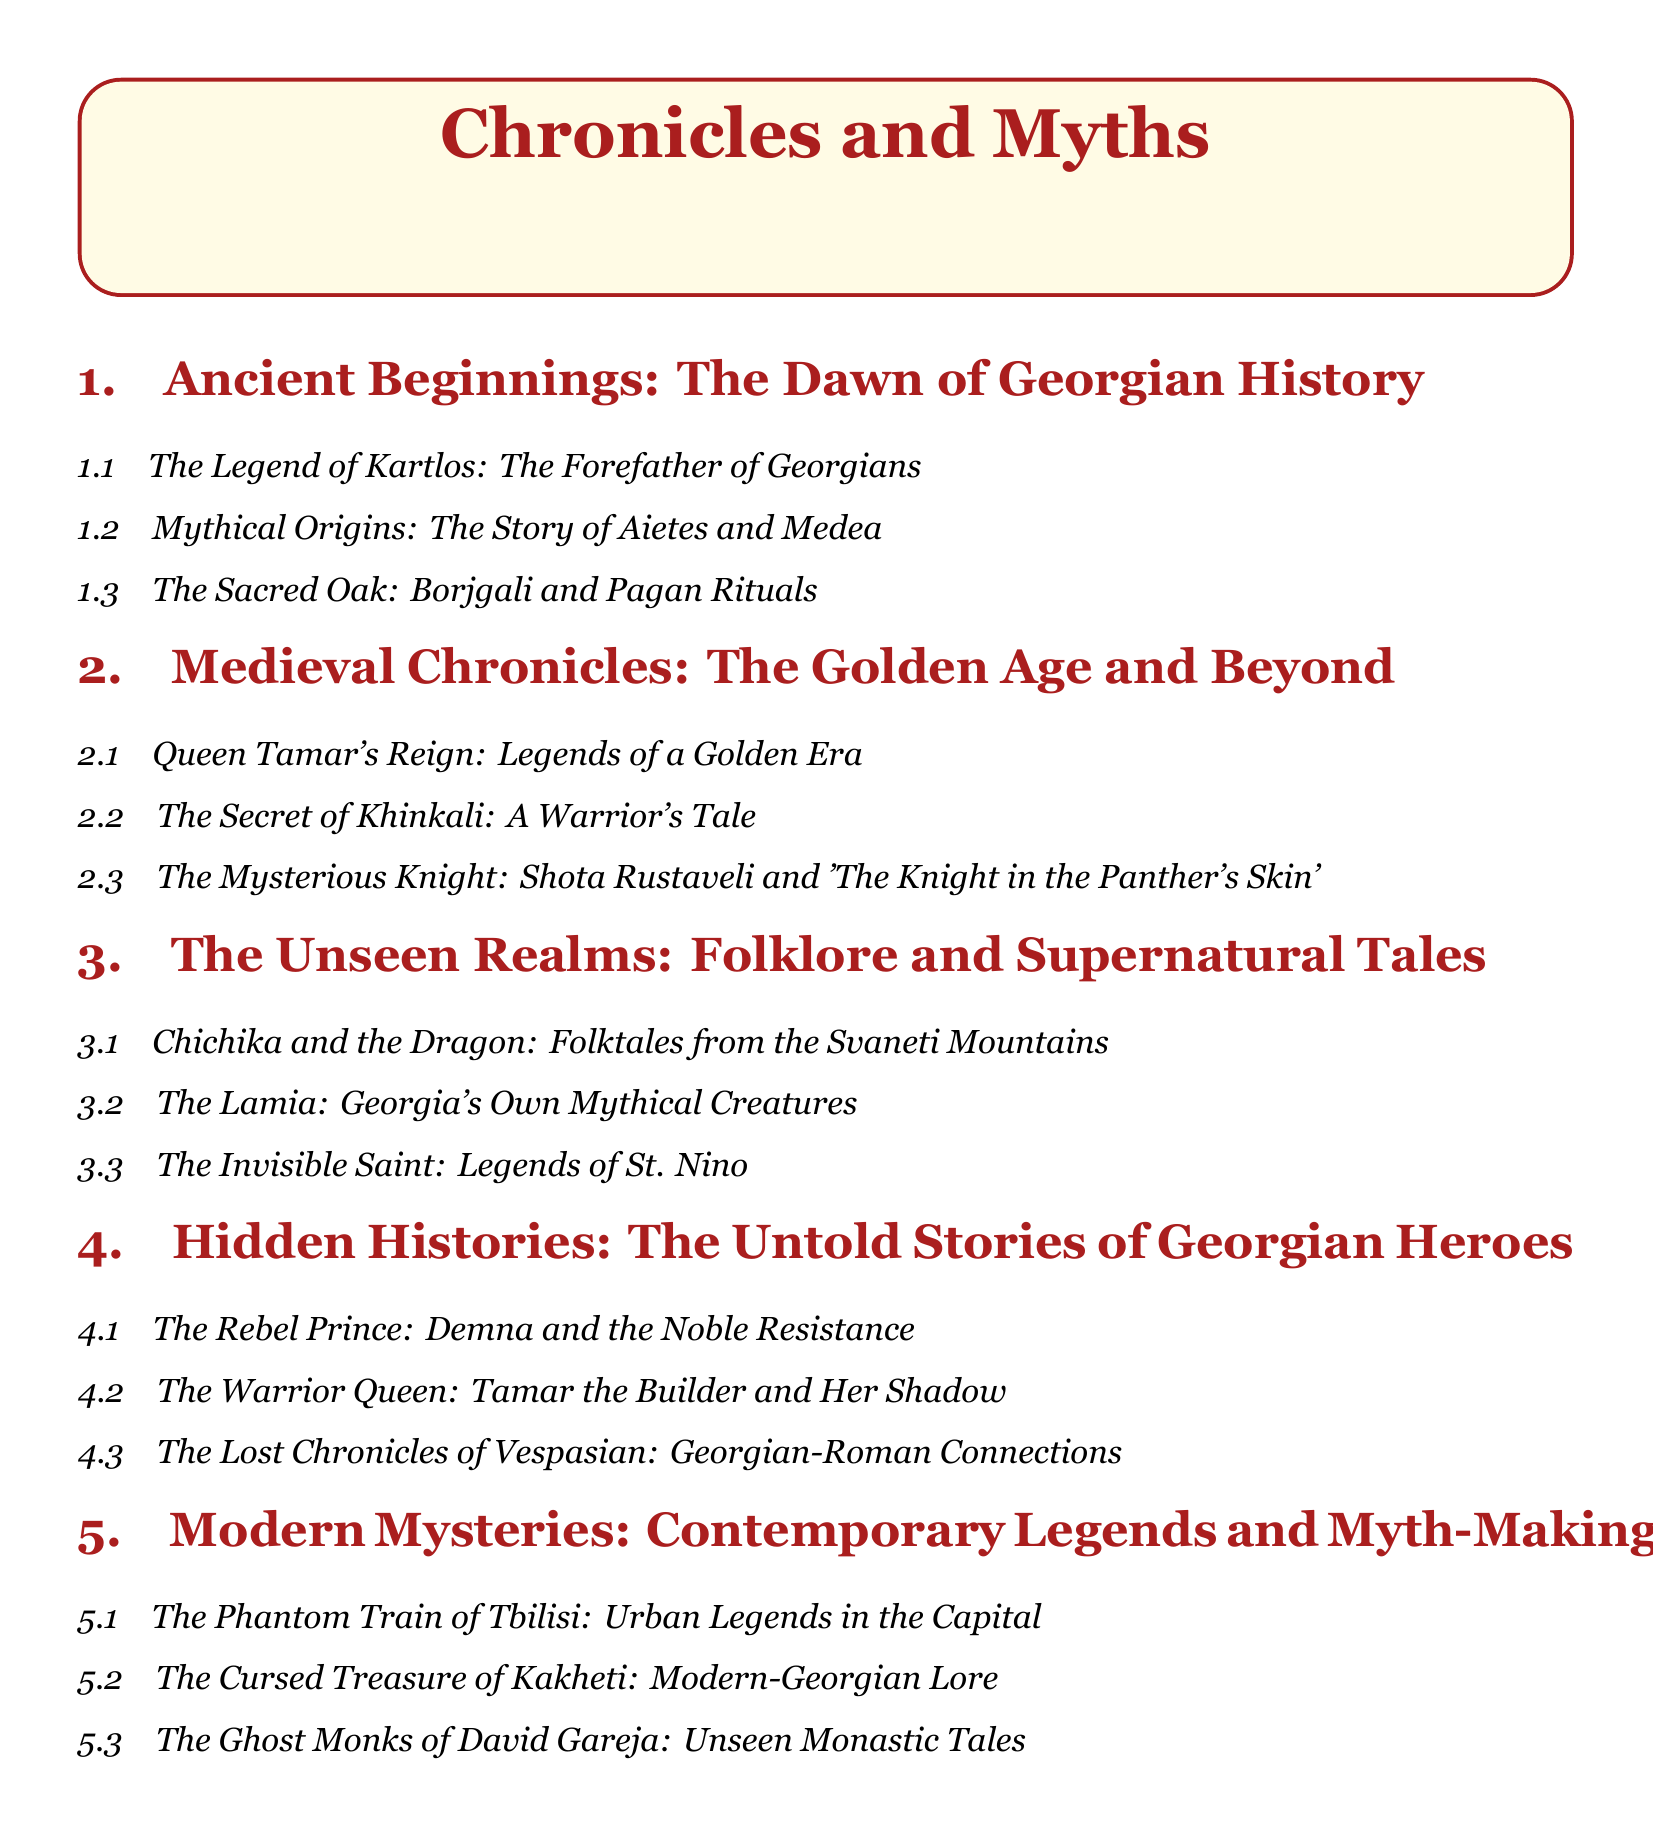What is the first section of the document? The first section is titled under "Ancient Beginnings," marking the start of the document's exploration into Georgian history.
Answer: Ancient Beginnings: The Dawn of Georgian History Who is referred to as the forefather of Georgians? The document specifically names Kartlos as the legendary forefather at the beginning of the Chronicles and Myths.
Answer: Kartlos What is the title of Shota Rustaveli's work mentioned? The document includes a specific title associated with Rustaveli, a central character in Georgian literature and history.
Answer: The Knight in the Panther's Skin How many subsections are there under "Hidden Histories"? This requires counting the subsections in the specified section of the document for accuracy.
Answer: Three What legendary figure is involved in the story of Medea? The document links Aietes with Medea, connecting these mythological figures to Georgian heritage.
Answer: Aietes What is the theme of the section titled "Modern Mysteries"? This section explores contemporary legends and tales that are unique to modern Georgian culture, indicating a focus on more recent stories.
Answer: Contemporary Legends and Myth-Making What mythological creature is mentioned in relation to Georgia? The document highlights a specific creature that is part of Georgian folklore, emphasizing its cultural significance.
Answer: Lamia Which historical queen is mentioned as "Tamar the Builder"? This title refers to a prominent Georgian figure, elaborating on her legacy and importance in Georgian history.
Answer: Tamar the Builder 